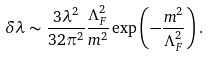Convert formula to latex. <formula><loc_0><loc_0><loc_500><loc_500>\delta \lambda \sim \frac { 3 \lambda ^ { 2 } } { 3 2 \pi ^ { 2 } } \frac { \Lambda ^ { 2 } _ { F } } { m ^ { 2 } } \exp \left ( - \frac { m ^ { 2 } } { \Lambda _ { F } ^ { 2 } } \right ) .</formula> 